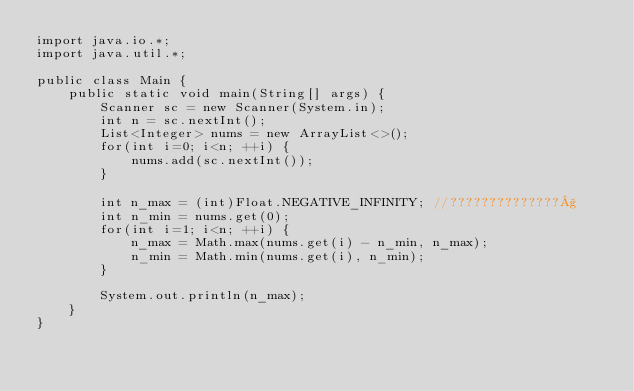Convert code to text. <code><loc_0><loc_0><loc_500><loc_500><_Java_>import java.io.*;
import java.util.*;

public class Main {
    public static void main(String[] args) {
        Scanner sc = new Scanner(System.in);
        int n = sc.nextInt();
        List<Integer> nums = new ArrayList<>();
        for(int i=0; i<n; ++i) {
            nums.add(sc.nextInt());
        }

        int n_max = (int)Float.NEGATIVE_INFINITY; //??????????????§
        int n_min = nums.get(0);
        for(int i=1; i<n; ++i) {
            n_max = Math.max(nums.get(i) - n_min, n_max);
            n_min = Math.min(nums.get(i), n_min);
        }

        System.out.println(n_max);
    }
}</code> 